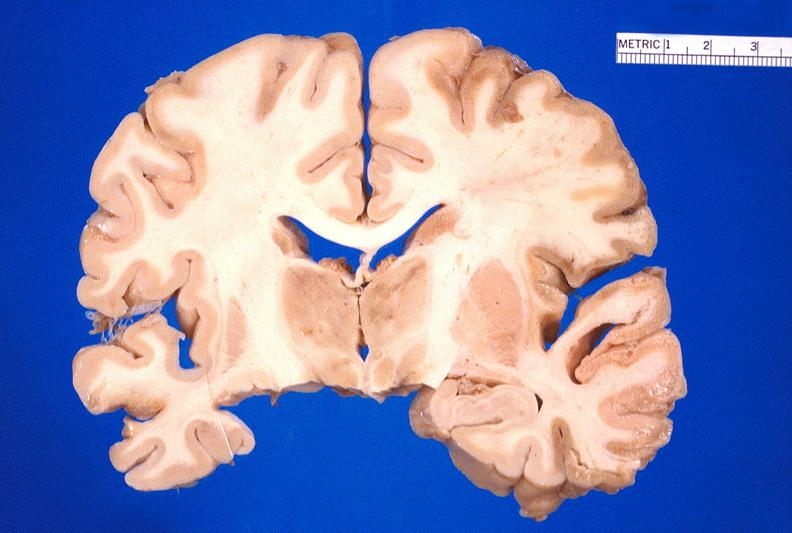what is present?
Answer the question using a single word or phrase. Nervous 